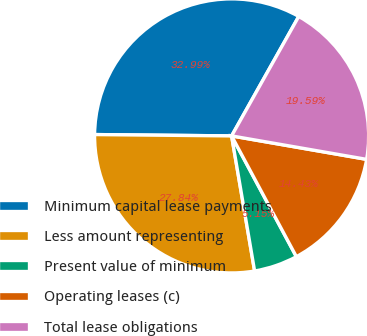Convert chart. <chart><loc_0><loc_0><loc_500><loc_500><pie_chart><fcel>Minimum capital lease payments<fcel>Less amount representing<fcel>Present value of minimum<fcel>Operating leases (c)<fcel>Total lease obligations<nl><fcel>32.99%<fcel>27.84%<fcel>5.15%<fcel>14.43%<fcel>19.59%<nl></chart> 